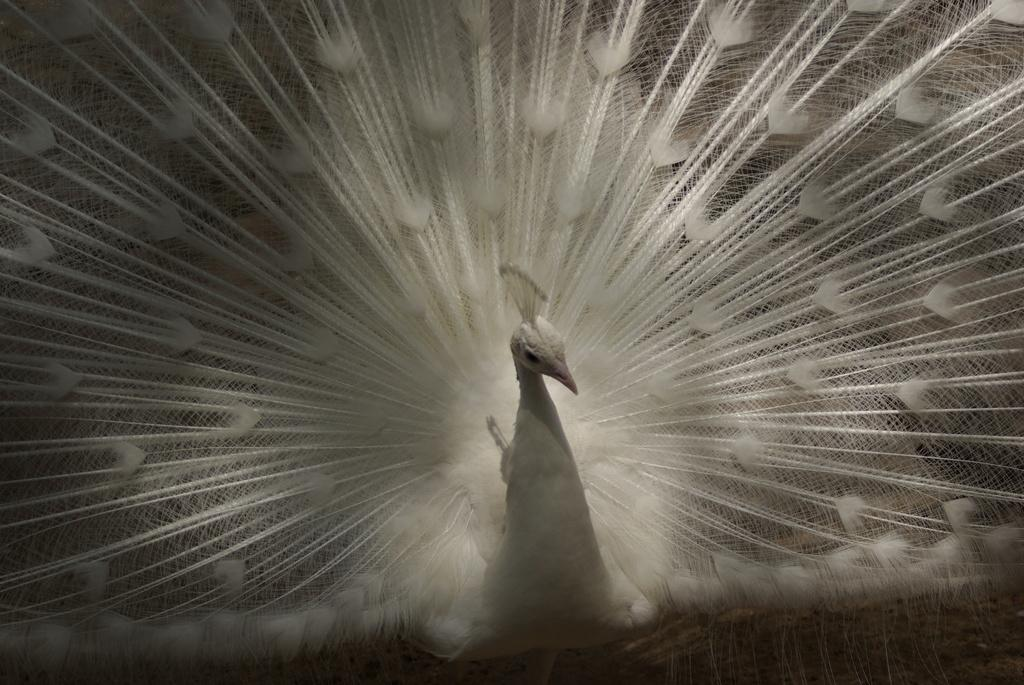What type of bird is in the picture? There is a white color peacock in the picture. Can you describe the floor visible in the image? The floor is visible in the bottom right corner of the image. What operation is being performed by the peacock in the image? There is no operation being performed by the peacock in the image; it is simply standing or posing. 